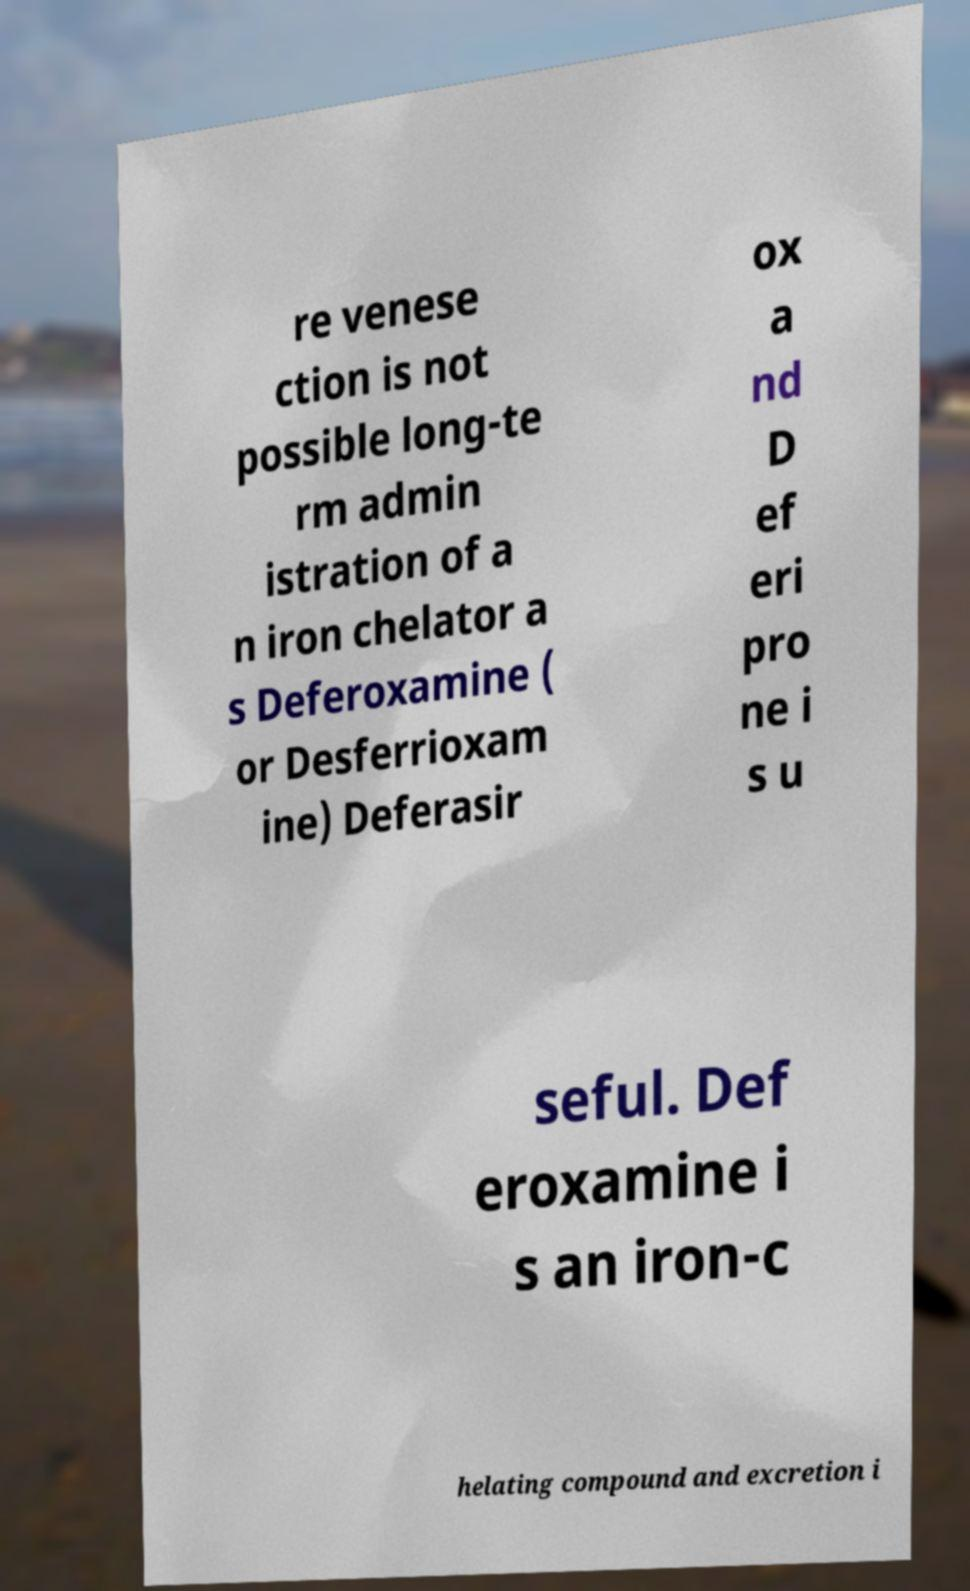I need the written content from this picture converted into text. Can you do that? re venese ction is not possible long-te rm admin istration of a n iron chelator a s Deferoxamine ( or Desferrioxam ine) Deferasir ox a nd D ef eri pro ne i s u seful. Def eroxamine i s an iron-c helating compound and excretion i 